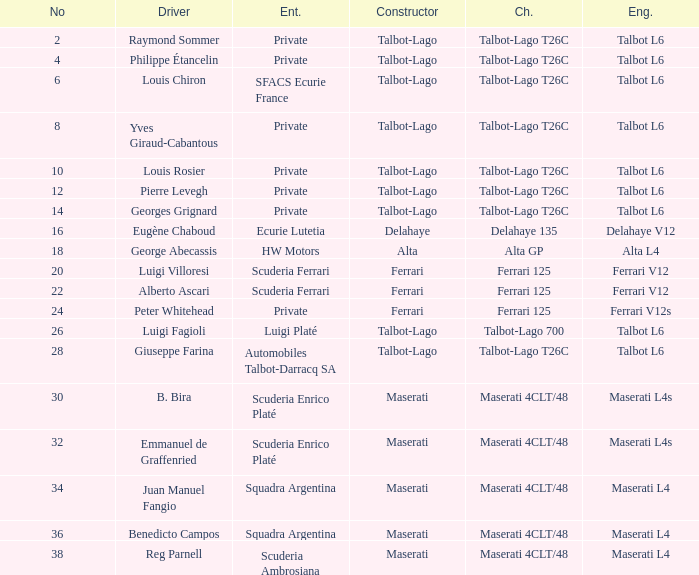Which chassis is associated with b. bira? Maserati 4CLT/48. 